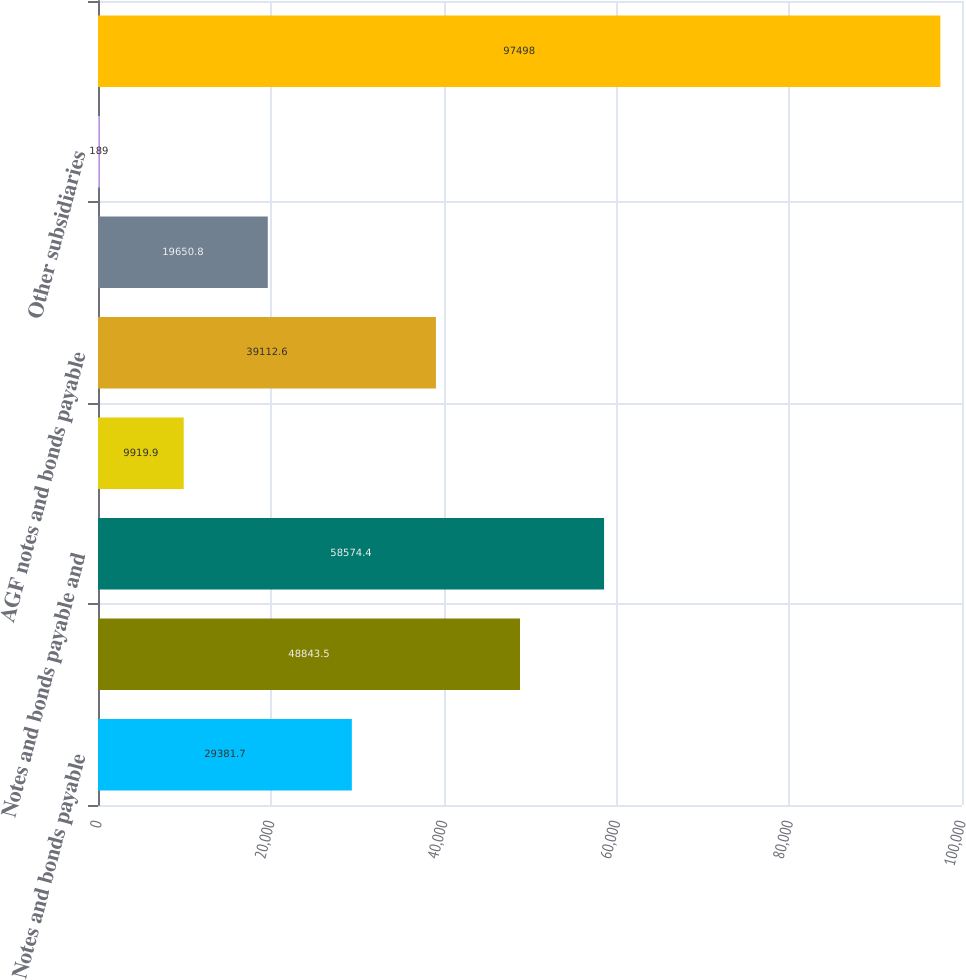Convert chart. <chart><loc_0><loc_0><loc_500><loc_500><bar_chart><fcel>Notes and bonds payable<fcel>GIAs<fcel>Notes and bonds payable and<fcel>ILFC notes and bonds payable<fcel>AGF notes and bonds payable<fcel>AIGCFG loans and mortgages<fcel>Other subsidiaries<fcel>Total<nl><fcel>29381.7<fcel>48843.5<fcel>58574.4<fcel>9919.9<fcel>39112.6<fcel>19650.8<fcel>189<fcel>97498<nl></chart> 